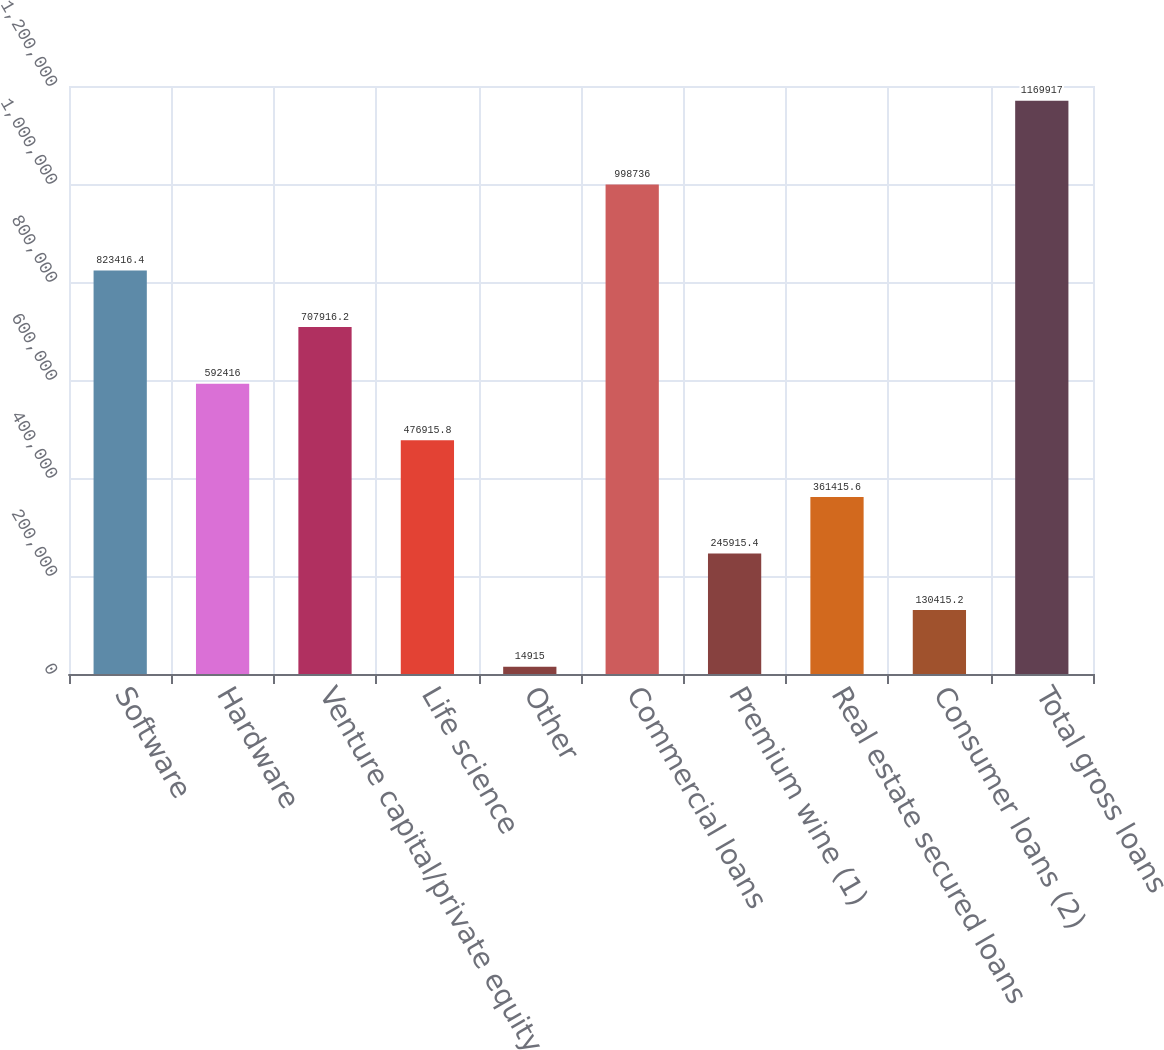Convert chart. <chart><loc_0><loc_0><loc_500><loc_500><bar_chart><fcel>Software<fcel>Hardware<fcel>Venture capital/private equity<fcel>Life science<fcel>Other<fcel>Commercial loans<fcel>Premium wine (1)<fcel>Real estate secured loans<fcel>Consumer loans (2)<fcel>Total gross loans<nl><fcel>823416<fcel>592416<fcel>707916<fcel>476916<fcel>14915<fcel>998736<fcel>245915<fcel>361416<fcel>130415<fcel>1.16992e+06<nl></chart> 